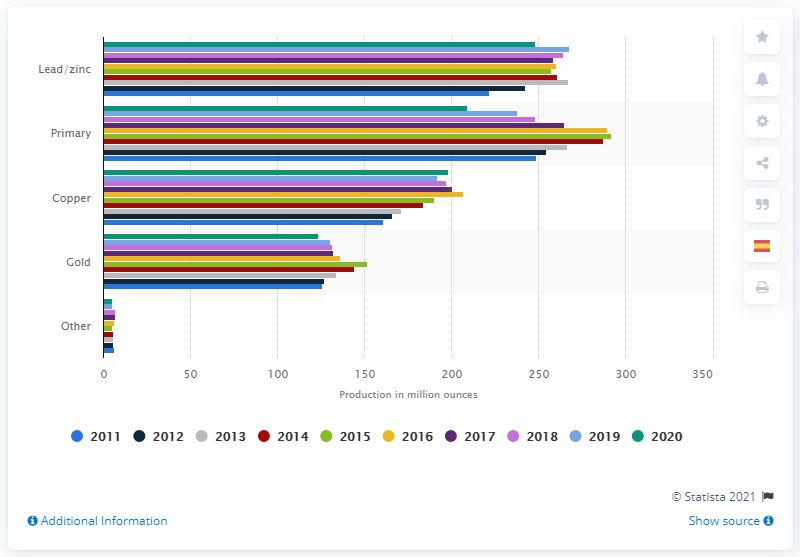Specify some key components in this picture. In 2020, approximately 123.3% of the world's silver production was a by-product of gold production. 